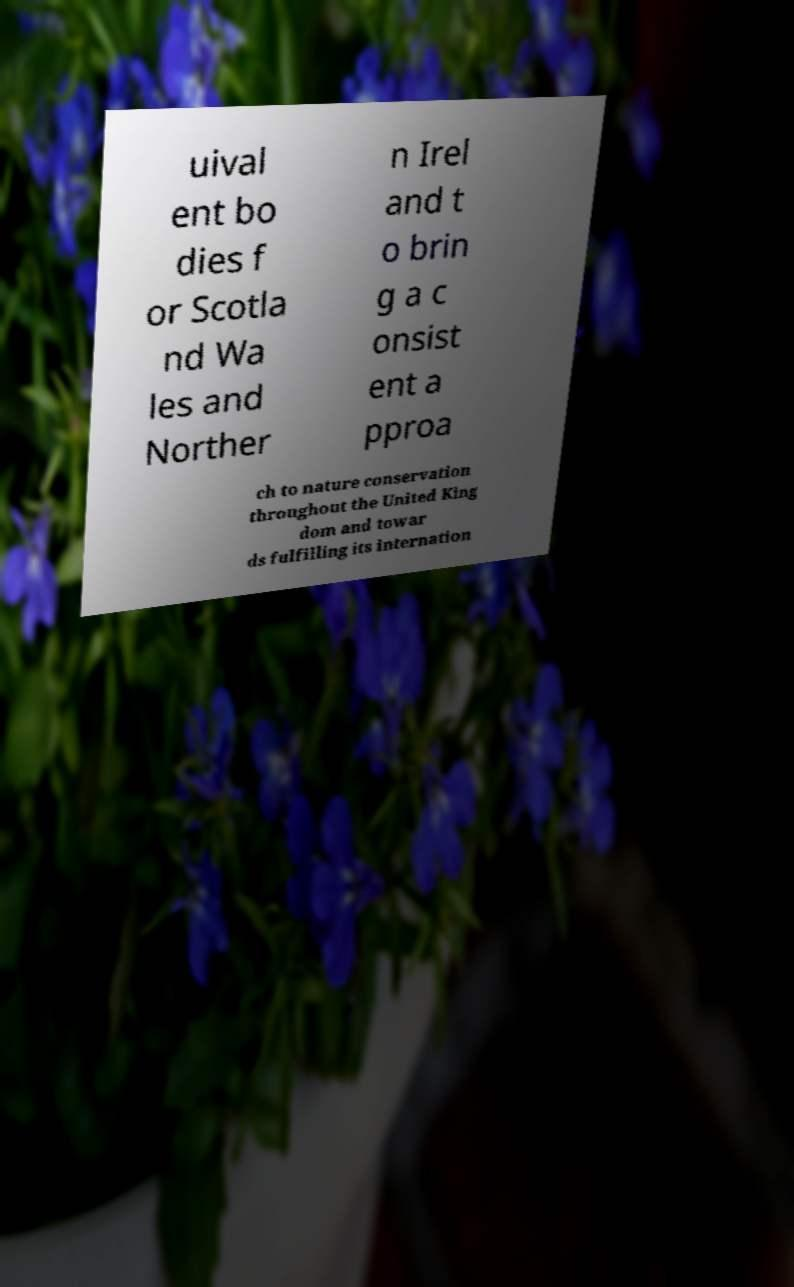There's text embedded in this image that I need extracted. Can you transcribe it verbatim? uival ent bo dies f or Scotla nd Wa les and Norther n Irel and t o brin g a c onsist ent a pproa ch to nature conservation throughout the United King dom and towar ds fulfilling its internation 